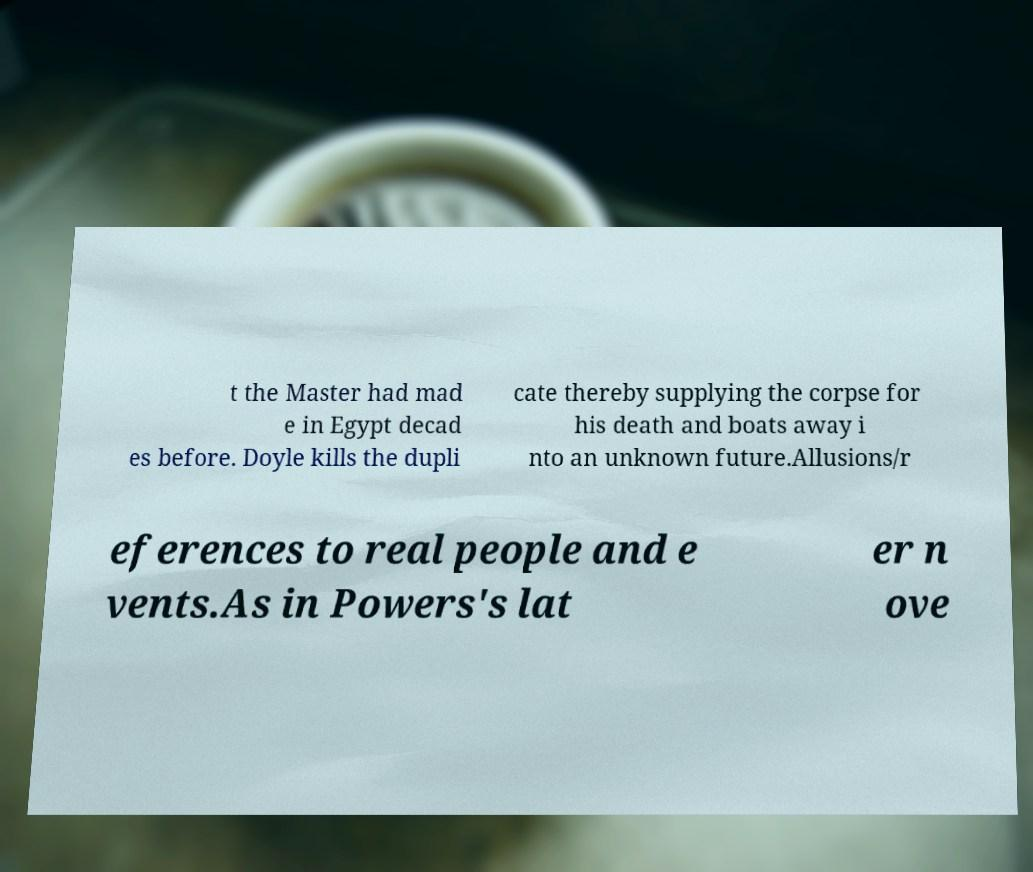For documentation purposes, I need the text within this image transcribed. Could you provide that? t the Master had mad e in Egypt decad es before. Doyle kills the dupli cate thereby supplying the corpse for his death and boats away i nto an unknown future.Allusions/r eferences to real people and e vents.As in Powers's lat er n ove 